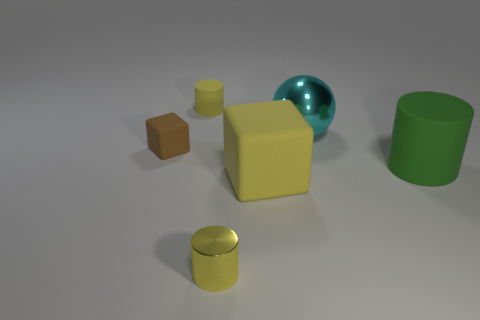Are there any colors that predominate in the image, and what mood do they create? The image features a muted color palette with tones of yellow, green, blue-green, and brown. These colors are generally considered soothing and can evoke a sense of tranquility and balance. The soft colors, in combination with the simple arrangement of objects, create a minimalist aesthetic that is calming and easy to view. 